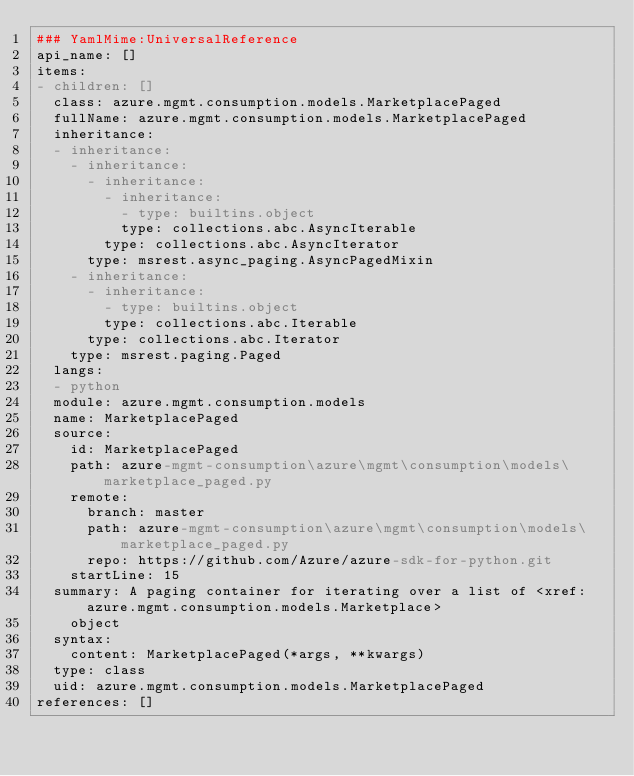Convert code to text. <code><loc_0><loc_0><loc_500><loc_500><_YAML_>### YamlMime:UniversalReference
api_name: []
items:
- children: []
  class: azure.mgmt.consumption.models.MarketplacePaged
  fullName: azure.mgmt.consumption.models.MarketplacePaged
  inheritance:
  - inheritance:
    - inheritance:
      - inheritance:
        - inheritance:
          - type: builtins.object
          type: collections.abc.AsyncIterable
        type: collections.abc.AsyncIterator
      type: msrest.async_paging.AsyncPagedMixin
    - inheritance:
      - inheritance:
        - type: builtins.object
        type: collections.abc.Iterable
      type: collections.abc.Iterator
    type: msrest.paging.Paged
  langs:
  - python
  module: azure.mgmt.consumption.models
  name: MarketplacePaged
  source:
    id: MarketplacePaged
    path: azure-mgmt-consumption\azure\mgmt\consumption\models\marketplace_paged.py
    remote:
      branch: master
      path: azure-mgmt-consumption\azure\mgmt\consumption\models\marketplace_paged.py
      repo: https://github.com/Azure/azure-sdk-for-python.git
    startLine: 15
  summary: A paging container for iterating over a list of <xref:azure.mgmt.consumption.models.Marketplace>
    object
  syntax:
    content: MarketplacePaged(*args, **kwargs)
  type: class
  uid: azure.mgmt.consumption.models.MarketplacePaged
references: []
</code> 